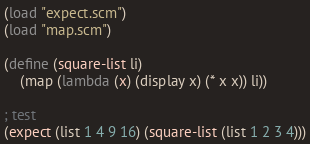Convert code to text. <code><loc_0><loc_0><loc_500><loc_500><_Scheme_>(load "expect.scm")
(load "map.scm")

(define (square-list li)
    (map (lambda (x) (display x) (* x x)) li))

; test
(expect (list 1 4 9 16) (square-list (list 1 2 3 4)))
</code> 